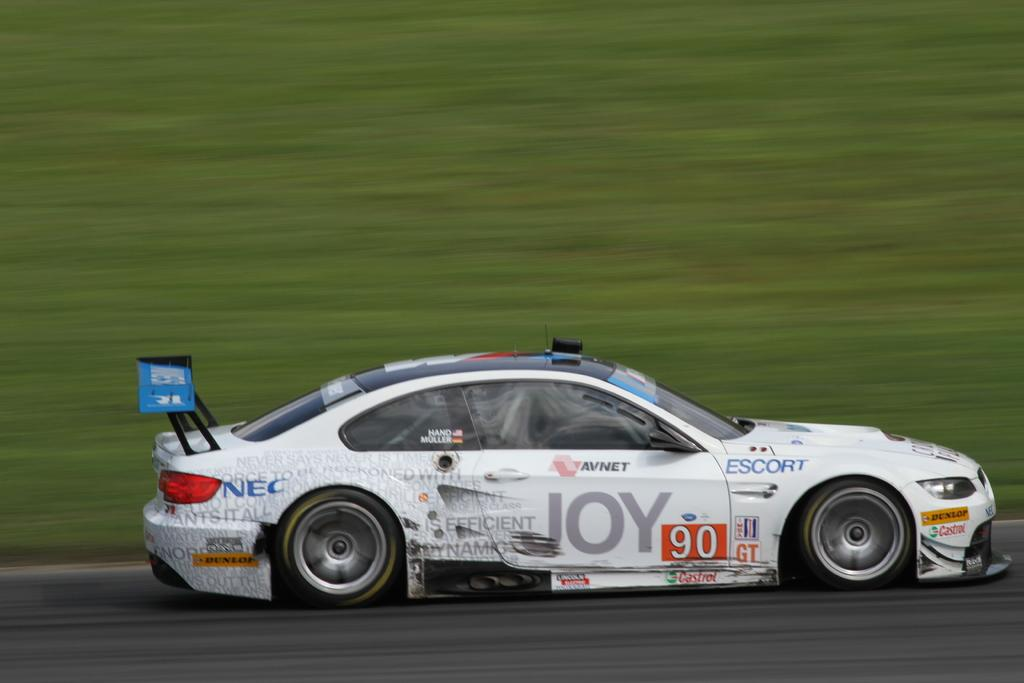What is the main subject of the image? The main subject of the image is a car. Where is the car located in the image? The car is on the road in the image. What can be seen in the background of the image? There is grass visible in the background of the image. What type of stamp is being used to hold the car in place in the image? There is no stamp present in the image, and the car is not being held in place. 